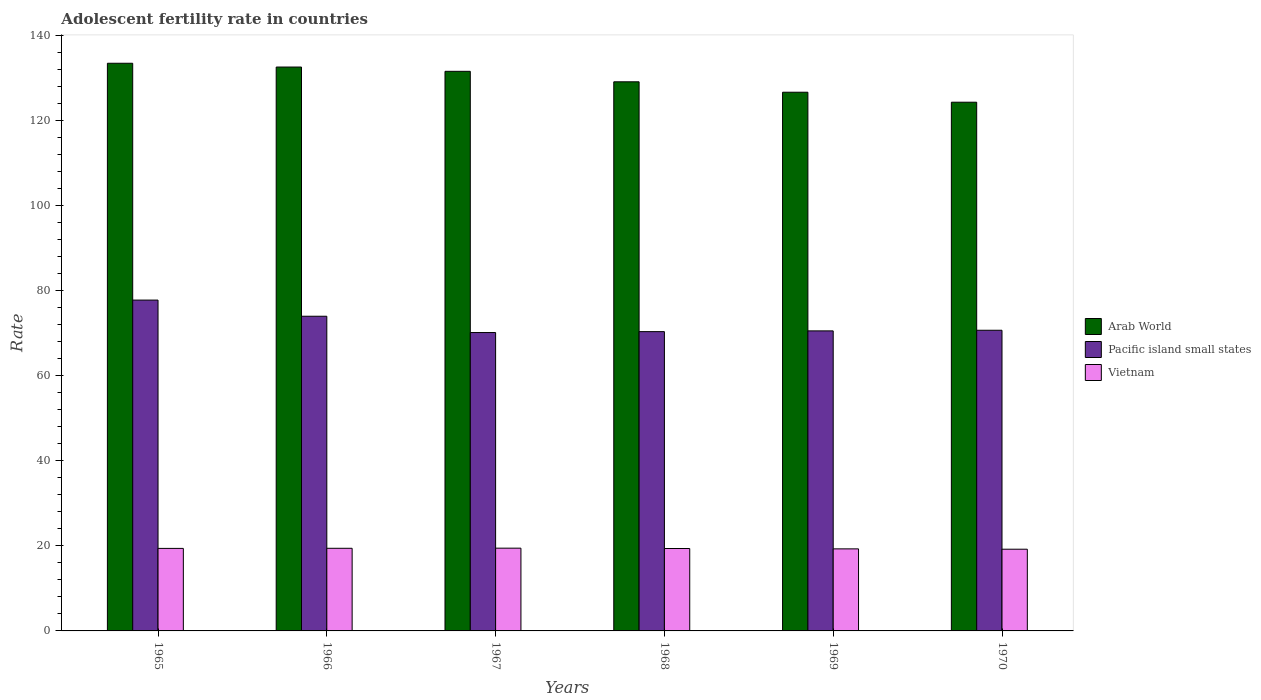How many different coloured bars are there?
Make the answer very short. 3. Are the number of bars per tick equal to the number of legend labels?
Ensure brevity in your answer.  Yes. Are the number of bars on each tick of the X-axis equal?
Your response must be concise. Yes. What is the label of the 4th group of bars from the left?
Offer a terse response. 1968. What is the adolescent fertility rate in Pacific island small states in 1969?
Make the answer very short. 70.6. Across all years, what is the maximum adolescent fertility rate in Pacific island small states?
Offer a terse response. 77.84. Across all years, what is the minimum adolescent fertility rate in Pacific island small states?
Your answer should be very brief. 70.21. In which year was the adolescent fertility rate in Vietnam maximum?
Ensure brevity in your answer.  1967. What is the total adolescent fertility rate in Vietnam in the graph?
Ensure brevity in your answer.  116.25. What is the difference between the adolescent fertility rate in Vietnam in 1965 and that in 1966?
Offer a very short reply. -0.03. What is the difference between the adolescent fertility rate in Arab World in 1966 and the adolescent fertility rate in Vietnam in 1967?
Offer a very short reply. 113.21. What is the average adolescent fertility rate in Arab World per year?
Make the answer very short. 129.71. In the year 1970, what is the difference between the adolescent fertility rate in Vietnam and adolescent fertility rate in Arab World?
Your answer should be very brief. -105.18. What is the ratio of the adolescent fertility rate in Vietnam in 1967 to that in 1968?
Make the answer very short. 1. Is the difference between the adolescent fertility rate in Vietnam in 1966 and 1968 greater than the difference between the adolescent fertility rate in Arab World in 1966 and 1968?
Your answer should be compact. No. What is the difference between the highest and the second highest adolescent fertility rate in Arab World?
Ensure brevity in your answer.  0.89. What is the difference between the highest and the lowest adolescent fertility rate in Vietnam?
Make the answer very short. 0.25. Is the sum of the adolescent fertility rate in Pacific island small states in 1967 and 1970 greater than the maximum adolescent fertility rate in Arab World across all years?
Ensure brevity in your answer.  Yes. What does the 2nd bar from the left in 1970 represents?
Your response must be concise. Pacific island small states. What does the 3rd bar from the right in 1967 represents?
Ensure brevity in your answer.  Arab World. How many bars are there?
Provide a succinct answer. 18. Are all the bars in the graph horizontal?
Make the answer very short. No. How many years are there in the graph?
Offer a very short reply. 6. Where does the legend appear in the graph?
Your answer should be very brief. Center right. What is the title of the graph?
Provide a short and direct response. Adolescent fertility rate in countries. Does "Venezuela" appear as one of the legend labels in the graph?
Your answer should be compact. No. What is the label or title of the Y-axis?
Ensure brevity in your answer.  Rate. What is the Rate of Arab World in 1965?
Your answer should be very brief. 133.57. What is the Rate in Pacific island small states in 1965?
Offer a very short reply. 77.84. What is the Rate in Vietnam in 1965?
Offer a terse response. 19.42. What is the Rate in Arab World in 1966?
Your answer should be compact. 132.68. What is the Rate in Pacific island small states in 1966?
Your response must be concise. 74.04. What is the Rate in Vietnam in 1966?
Give a very brief answer. 19.44. What is the Rate in Arab World in 1967?
Make the answer very short. 131.67. What is the Rate in Pacific island small states in 1967?
Keep it short and to the point. 70.21. What is the Rate of Vietnam in 1967?
Your answer should be very brief. 19.47. What is the Rate of Arab World in 1968?
Provide a succinct answer. 129.2. What is the Rate in Pacific island small states in 1968?
Give a very brief answer. 70.42. What is the Rate of Vietnam in 1968?
Offer a terse response. 19.39. What is the Rate in Arab World in 1969?
Offer a very short reply. 126.75. What is the Rate in Pacific island small states in 1969?
Keep it short and to the point. 70.6. What is the Rate in Vietnam in 1969?
Offer a terse response. 19.31. What is the Rate in Arab World in 1970?
Provide a succinct answer. 124.4. What is the Rate of Pacific island small states in 1970?
Make the answer very short. 70.74. What is the Rate of Vietnam in 1970?
Provide a succinct answer. 19.23. Across all years, what is the maximum Rate in Arab World?
Keep it short and to the point. 133.57. Across all years, what is the maximum Rate in Pacific island small states?
Your response must be concise. 77.84. Across all years, what is the maximum Rate in Vietnam?
Offer a very short reply. 19.47. Across all years, what is the minimum Rate in Arab World?
Ensure brevity in your answer.  124.4. Across all years, what is the minimum Rate in Pacific island small states?
Provide a succinct answer. 70.21. Across all years, what is the minimum Rate of Vietnam?
Keep it short and to the point. 19.23. What is the total Rate of Arab World in the graph?
Offer a very short reply. 778.28. What is the total Rate of Pacific island small states in the graph?
Your response must be concise. 433.86. What is the total Rate of Vietnam in the graph?
Provide a short and direct response. 116.25. What is the difference between the Rate in Arab World in 1965 and that in 1966?
Ensure brevity in your answer.  0.89. What is the difference between the Rate of Pacific island small states in 1965 and that in 1966?
Make the answer very short. 3.8. What is the difference between the Rate of Vietnam in 1965 and that in 1966?
Ensure brevity in your answer.  -0.03. What is the difference between the Rate of Arab World in 1965 and that in 1967?
Give a very brief answer. 1.9. What is the difference between the Rate in Pacific island small states in 1965 and that in 1967?
Your answer should be compact. 7.64. What is the difference between the Rate of Vietnam in 1965 and that in 1967?
Your answer should be compact. -0.06. What is the difference between the Rate in Arab World in 1965 and that in 1968?
Provide a succinct answer. 4.36. What is the difference between the Rate of Pacific island small states in 1965 and that in 1968?
Offer a very short reply. 7.42. What is the difference between the Rate in Vietnam in 1965 and that in 1968?
Keep it short and to the point. 0.03. What is the difference between the Rate of Arab World in 1965 and that in 1969?
Provide a short and direct response. 6.81. What is the difference between the Rate in Pacific island small states in 1965 and that in 1969?
Keep it short and to the point. 7.25. What is the difference between the Rate in Vietnam in 1965 and that in 1969?
Ensure brevity in your answer.  0.11. What is the difference between the Rate of Arab World in 1965 and that in 1970?
Make the answer very short. 9.16. What is the difference between the Rate of Pacific island small states in 1965 and that in 1970?
Provide a short and direct response. 7.1. What is the difference between the Rate in Vietnam in 1965 and that in 1970?
Your answer should be compact. 0.19. What is the difference between the Rate in Pacific island small states in 1966 and that in 1967?
Give a very brief answer. 3.84. What is the difference between the Rate in Vietnam in 1966 and that in 1967?
Your answer should be compact. -0.03. What is the difference between the Rate of Arab World in 1966 and that in 1968?
Your answer should be compact. 3.47. What is the difference between the Rate of Pacific island small states in 1966 and that in 1968?
Offer a terse response. 3.62. What is the difference between the Rate in Vietnam in 1966 and that in 1968?
Offer a terse response. 0.05. What is the difference between the Rate of Arab World in 1966 and that in 1969?
Ensure brevity in your answer.  5.92. What is the difference between the Rate of Pacific island small states in 1966 and that in 1969?
Make the answer very short. 3.44. What is the difference between the Rate in Vietnam in 1966 and that in 1969?
Provide a succinct answer. 0.14. What is the difference between the Rate of Arab World in 1966 and that in 1970?
Offer a terse response. 8.27. What is the difference between the Rate in Pacific island small states in 1966 and that in 1970?
Offer a terse response. 3.3. What is the difference between the Rate of Vietnam in 1966 and that in 1970?
Keep it short and to the point. 0.22. What is the difference between the Rate of Arab World in 1967 and that in 1968?
Offer a very short reply. 2.47. What is the difference between the Rate in Pacific island small states in 1967 and that in 1968?
Offer a very short reply. -0.21. What is the difference between the Rate in Vietnam in 1967 and that in 1968?
Offer a very short reply. 0.08. What is the difference between the Rate in Arab World in 1967 and that in 1969?
Give a very brief answer. 4.92. What is the difference between the Rate in Pacific island small states in 1967 and that in 1969?
Your answer should be compact. -0.39. What is the difference between the Rate in Vietnam in 1967 and that in 1969?
Give a very brief answer. 0.16. What is the difference between the Rate in Arab World in 1967 and that in 1970?
Provide a succinct answer. 7.27. What is the difference between the Rate of Pacific island small states in 1967 and that in 1970?
Provide a succinct answer. -0.54. What is the difference between the Rate in Vietnam in 1967 and that in 1970?
Offer a very short reply. 0.25. What is the difference between the Rate in Arab World in 1968 and that in 1969?
Make the answer very short. 2.45. What is the difference between the Rate in Pacific island small states in 1968 and that in 1969?
Your response must be concise. -0.18. What is the difference between the Rate in Vietnam in 1968 and that in 1969?
Provide a succinct answer. 0.08. What is the difference between the Rate in Arab World in 1968 and that in 1970?
Your answer should be very brief. 4.8. What is the difference between the Rate of Pacific island small states in 1968 and that in 1970?
Your answer should be very brief. -0.32. What is the difference between the Rate of Vietnam in 1968 and that in 1970?
Your answer should be very brief. 0.16. What is the difference between the Rate in Arab World in 1969 and that in 1970?
Give a very brief answer. 2.35. What is the difference between the Rate of Pacific island small states in 1969 and that in 1970?
Make the answer very short. -0.14. What is the difference between the Rate in Vietnam in 1969 and that in 1970?
Provide a short and direct response. 0.08. What is the difference between the Rate in Arab World in 1965 and the Rate in Pacific island small states in 1966?
Offer a terse response. 59.52. What is the difference between the Rate of Arab World in 1965 and the Rate of Vietnam in 1966?
Ensure brevity in your answer.  114.12. What is the difference between the Rate of Pacific island small states in 1965 and the Rate of Vietnam in 1966?
Offer a very short reply. 58.4. What is the difference between the Rate in Arab World in 1965 and the Rate in Pacific island small states in 1967?
Offer a terse response. 63.36. What is the difference between the Rate in Arab World in 1965 and the Rate in Vietnam in 1967?
Provide a succinct answer. 114.1. What is the difference between the Rate in Pacific island small states in 1965 and the Rate in Vietnam in 1967?
Offer a very short reply. 58.37. What is the difference between the Rate of Arab World in 1965 and the Rate of Pacific island small states in 1968?
Provide a succinct answer. 63.15. What is the difference between the Rate of Arab World in 1965 and the Rate of Vietnam in 1968?
Keep it short and to the point. 114.18. What is the difference between the Rate in Pacific island small states in 1965 and the Rate in Vietnam in 1968?
Give a very brief answer. 58.45. What is the difference between the Rate of Arab World in 1965 and the Rate of Pacific island small states in 1969?
Make the answer very short. 62.97. What is the difference between the Rate of Arab World in 1965 and the Rate of Vietnam in 1969?
Provide a short and direct response. 114.26. What is the difference between the Rate in Pacific island small states in 1965 and the Rate in Vietnam in 1969?
Ensure brevity in your answer.  58.54. What is the difference between the Rate of Arab World in 1965 and the Rate of Pacific island small states in 1970?
Provide a short and direct response. 62.83. What is the difference between the Rate in Arab World in 1965 and the Rate in Vietnam in 1970?
Provide a short and direct response. 114.34. What is the difference between the Rate of Pacific island small states in 1965 and the Rate of Vietnam in 1970?
Your answer should be compact. 58.62. What is the difference between the Rate of Arab World in 1966 and the Rate of Pacific island small states in 1967?
Keep it short and to the point. 62.47. What is the difference between the Rate of Arab World in 1966 and the Rate of Vietnam in 1967?
Your response must be concise. 113.21. What is the difference between the Rate in Pacific island small states in 1966 and the Rate in Vietnam in 1967?
Keep it short and to the point. 54.57. What is the difference between the Rate of Arab World in 1966 and the Rate of Pacific island small states in 1968?
Ensure brevity in your answer.  62.25. What is the difference between the Rate of Arab World in 1966 and the Rate of Vietnam in 1968?
Your answer should be compact. 113.29. What is the difference between the Rate in Pacific island small states in 1966 and the Rate in Vietnam in 1968?
Your answer should be compact. 54.65. What is the difference between the Rate of Arab World in 1966 and the Rate of Pacific island small states in 1969?
Offer a terse response. 62.08. What is the difference between the Rate in Arab World in 1966 and the Rate in Vietnam in 1969?
Your answer should be very brief. 113.37. What is the difference between the Rate in Pacific island small states in 1966 and the Rate in Vietnam in 1969?
Ensure brevity in your answer.  54.74. What is the difference between the Rate of Arab World in 1966 and the Rate of Pacific island small states in 1970?
Offer a very short reply. 61.93. What is the difference between the Rate of Arab World in 1966 and the Rate of Vietnam in 1970?
Ensure brevity in your answer.  113.45. What is the difference between the Rate in Pacific island small states in 1966 and the Rate in Vietnam in 1970?
Your answer should be very brief. 54.82. What is the difference between the Rate in Arab World in 1967 and the Rate in Pacific island small states in 1968?
Offer a terse response. 61.25. What is the difference between the Rate of Arab World in 1967 and the Rate of Vietnam in 1968?
Ensure brevity in your answer.  112.28. What is the difference between the Rate of Pacific island small states in 1967 and the Rate of Vietnam in 1968?
Provide a short and direct response. 50.82. What is the difference between the Rate in Arab World in 1967 and the Rate in Pacific island small states in 1969?
Provide a succinct answer. 61.07. What is the difference between the Rate in Arab World in 1967 and the Rate in Vietnam in 1969?
Make the answer very short. 112.36. What is the difference between the Rate of Pacific island small states in 1967 and the Rate of Vietnam in 1969?
Offer a very short reply. 50.9. What is the difference between the Rate of Arab World in 1967 and the Rate of Pacific island small states in 1970?
Ensure brevity in your answer.  60.93. What is the difference between the Rate in Arab World in 1967 and the Rate in Vietnam in 1970?
Your response must be concise. 112.45. What is the difference between the Rate in Pacific island small states in 1967 and the Rate in Vietnam in 1970?
Provide a succinct answer. 50.98. What is the difference between the Rate in Arab World in 1968 and the Rate in Pacific island small states in 1969?
Provide a succinct answer. 58.6. What is the difference between the Rate in Arab World in 1968 and the Rate in Vietnam in 1969?
Ensure brevity in your answer.  109.9. What is the difference between the Rate of Pacific island small states in 1968 and the Rate of Vietnam in 1969?
Your response must be concise. 51.11. What is the difference between the Rate of Arab World in 1968 and the Rate of Pacific island small states in 1970?
Your response must be concise. 58.46. What is the difference between the Rate of Arab World in 1968 and the Rate of Vietnam in 1970?
Give a very brief answer. 109.98. What is the difference between the Rate in Pacific island small states in 1968 and the Rate in Vietnam in 1970?
Your answer should be very brief. 51.2. What is the difference between the Rate in Arab World in 1969 and the Rate in Pacific island small states in 1970?
Your answer should be compact. 56.01. What is the difference between the Rate of Arab World in 1969 and the Rate of Vietnam in 1970?
Your answer should be compact. 107.53. What is the difference between the Rate in Pacific island small states in 1969 and the Rate in Vietnam in 1970?
Keep it short and to the point. 51.37. What is the average Rate of Arab World per year?
Provide a short and direct response. 129.71. What is the average Rate of Pacific island small states per year?
Keep it short and to the point. 72.31. What is the average Rate of Vietnam per year?
Your answer should be very brief. 19.38. In the year 1965, what is the difference between the Rate in Arab World and Rate in Pacific island small states?
Provide a short and direct response. 55.72. In the year 1965, what is the difference between the Rate in Arab World and Rate in Vietnam?
Your answer should be compact. 114.15. In the year 1965, what is the difference between the Rate in Pacific island small states and Rate in Vietnam?
Your answer should be very brief. 58.43. In the year 1966, what is the difference between the Rate of Arab World and Rate of Pacific island small states?
Your answer should be very brief. 58.63. In the year 1966, what is the difference between the Rate of Arab World and Rate of Vietnam?
Provide a short and direct response. 113.23. In the year 1966, what is the difference between the Rate in Pacific island small states and Rate in Vietnam?
Offer a terse response. 54.6. In the year 1967, what is the difference between the Rate in Arab World and Rate in Pacific island small states?
Offer a terse response. 61.47. In the year 1967, what is the difference between the Rate in Arab World and Rate in Vietnam?
Keep it short and to the point. 112.2. In the year 1967, what is the difference between the Rate in Pacific island small states and Rate in Vietnam?
Give a very brief answer. 50.74. In the year 1968, what is the difference between the Rate in Arab World and Rate in Pacific island small states?
Your answer should be compact. 58.78. In the year 1968, what is the difference between the Rate of Arab World and Rate of Vietnam?
Ensure brevity in your answer.  109.81. In the year 1968, what is the difference between the Rate of Pacific island small states and Rate of Vietnam?
Keep it short and to the point. 51.03. In the year 1969, what is the difference between the Rate of Arab World and Rate of Pacific island small states?
Your answer should be very brief. 56.15. In the year 1969, what is the difference between the Rate of Arab World and Rate of Vietnam?
Give a very brief answer. 107.45. In the year 1969, what is the difference between the Rate in Pacific island small states and Rate in Vietnam?
Ensure brevity in your answer.  51.29. In the year 1970, what is the difference between the Rate of Arab World and Rate of Pacific island small states?
Provide a succinct answer. 53.66. In the year 1970, what is the difference between the Rate in Arab World and Rate in Vietnam?
Provide a succinct answer. 105.18. In the year 1970, what is the difference between the Rate of Pacific island small states and Rate of Vietnam?
Your response must be concise. 51.52. What is the ratio of the Rate in Pacific island small states in 1965 to that in 1966?
Keep it short and to the point. 1.05. What is the ratio of the Rate of Arab World in 1965 to that in 1967?
Keep it short and to the point. 1.01. What is the ratio of the Rate in Pacific island small states in 1965 to that in 1967?
Keep it short and to the point. 1.11. What is the ratio of the Rate in Arab World in 1965 to that in 1968?
Offer a terse response. 1.03. What is the ratio of the Rate of Pacific island small states in 1965 to that in 1968?
Your response must be concise. 1.11. What is the ratio of the Rate of Arab World in 1965 to that in 1969?
Your answer should be compact. 1.05. What is the ratio of the Rate in Pacific island small states in 1965 to that in 1969?
Ensure brevity in your answer.  1.1. What is the ratio of the Rate in Vietnam in 1965 to that in 1969?
Give a very brief answer. 1.01. What is the ratio of the Rate in Arab World in 1965 to that in 1970?
Offer a terse response. 1.07. What is the ratio of the Rate of Pacific island small states in 1965 to that in 1970?
Your response must be concise. 1.1. What is the ratio of the Rate of Vietnam in 1965 to that in 1970?
Ensure brevity in your answer.  1.01. What is the ratio of the Rate in Arab World in 1966 to that in 1967?
Make the answer very short. 1.01. What is the ratio of the Rate in Pacific island small states in 1966 to that in 1967?
Provide a short and direct response. 1.05. What is the ratio of the Rate of Vietnam in 1966 to that in 1967?
Give a very brief answer. 1. What is the ratio of the Rate in Arab World in 1966 to that in 1968?
Make the answer very short. 1.03. What is the ratio of the Rate in Pacific island small states in 1966 to that in 1968?
Your response must be concise. 1.05. What is the ratio of the Rate in Arab World in 1966 to that in 1969?
Give a very brief answer. 1.05. What is the ratio of the Rate of Pacific island small states in 1966 to that in 1969?
Make the answer very short. 1.05. What is the ratio of the Rate in Vietnam in 1966 to that in 1969?
Your answer should be compact. 1.01. What is the ratio of the Rate in Arab World in 1966 to that in 1970?
Keep it short and to the point. 1.07. What is the ratio of the Rate in Pacific island small states in 1966 to that in 1970?
Your response must be concise. 1.05. What is the ratio of the Rate in Vietnam in 1966 to that in 1970?
Offer a very short reply. 1.01. What is the ratio of the Rate in Arab World in 1967 to that in 1968?
Provide a succinct answer. 1.02. What is the ratio of the Rate of Vietnam in 1967 to that in 1968?
Give a very brief answer. 1. What is the ratio of the Rate of Arab World in 1967 to that in 1969?
Provide a short and direct response. 1.04. What is the ratio of the Rate in Vietnam in 1967 to that in 1969?
Your answer should be compact. 1.01. What is the ratio of the Rate of Arab World in 1967 to that in 1970?
Provide a succinct answer. 1.06. What is the ratio of the Rate of Vietnam in 1967 to that in 1970?
Provide a succinct answer. 1.01. What is the ratio of the Rate in Arab World in 1968 to that in 1969?
Offer a terse response. 1.02. What is the ratio of the Rate in Pacific island small states in 1968 to that in 1969?
Keep it short and to the point. 1. What is the ratio of the Rate of Vietnam in 1968 to that in 1969?
Your answer should be very brief. 1. What is the ratio of the Rate of Arab World in 1968 to that in 1970?
Your response must be concise. 1.04. What is the ratio of the Rate of Pacific island small states in 1968 to that in 1970?
Your answer should be compact. 1. What is the ratio of the Rate of Vietnam in 1968 to that in 1970?
Offer a very short reply. 1.01. What is the ratio of the Rate of Arab World in 1969 to that in 1970?
Make the answer very short. 1.02. What is the ratio of the Rate of Vietnam in 1969 to that in 1970?
Your answer should be very brief. 1. What is the difference between the highest and the second highest Rate of Arab World?
Ensure brevity in your answer.  0.89. What is the difference between the highest and the second highest Rate of Pacific island small states?
Offer a terse response. 3.8. What is the difference between the highest and the second highest Rate of Vietnam?
Your answer should be compact. 0.03. What is the difference between the highest and the lowest Rate of Arab World?
Your answer should be compact. 9.16. What is the difference between the highest and the lowest Rate in Pacific island small states?
Provide a succinct answer. 7.64. What is the difference between the highest and the lowest Rate in Vietnam?
Offer a terse response. 0.25. 